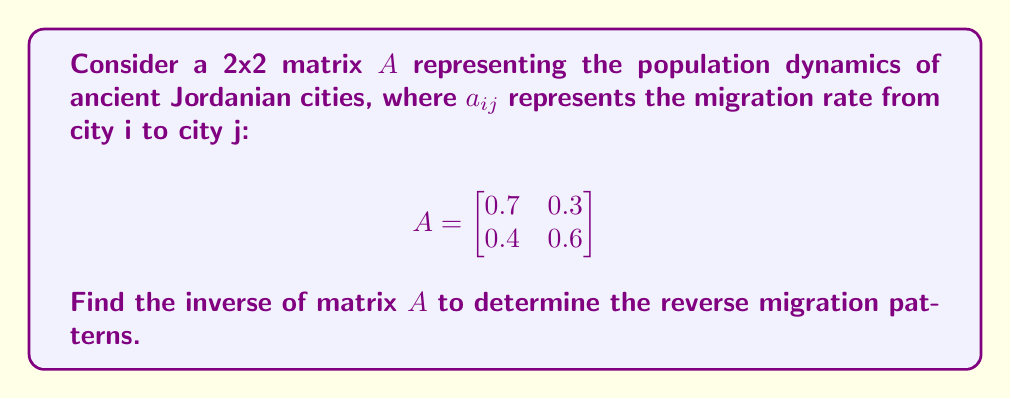Solve this math problem. To find the inverse of matrix $A$, we'll follow these steps:

1. Calculate the determinant of $A$:
   $\det(A) = (0.7)(0.6) - (0.3)(0.4) = 0.42 - 0.12 = 0.3$

2. Check if $A$ is invertible:
   Since $\det(A) \neq 0$, $A$ is invertible.

3. Find the adjugate matrix:
   $$\text{adj}(A) = \begin{bmatrix}
   0.6 & -0.3 \\
   -0.4 & 0.7
   \end{bmatrix}$$

4. Calculate $A^{-1}$ using the formula: $A^{-1} = \frac{1}{\det(A)} \cdot \text{adj}(A)$

   $$A^{-1} = \frac{1}{0.3} \cdot \begin{bmatrix}
   0.6 & -0.3 \\
   -0.4 & 0.7
   \end{bmatrix}$$

5. Simplify:
   $$A^{-1} = \begin{bmatrix}
   0.6/0.3 & -0.3/0.3 \\
   -0.4/0.3 & 0.7/0.3
   \end{bmatrix} = \begin{bmatrix}
   2 & -1 \\
   -4/3 & 7/3
   \end{bmatrix}$$
Answer: $$A^{-1} = \begin{bmatrix}
2 & -1 \\
-4/3 & 7/3
\end{bmatrix}$$ 